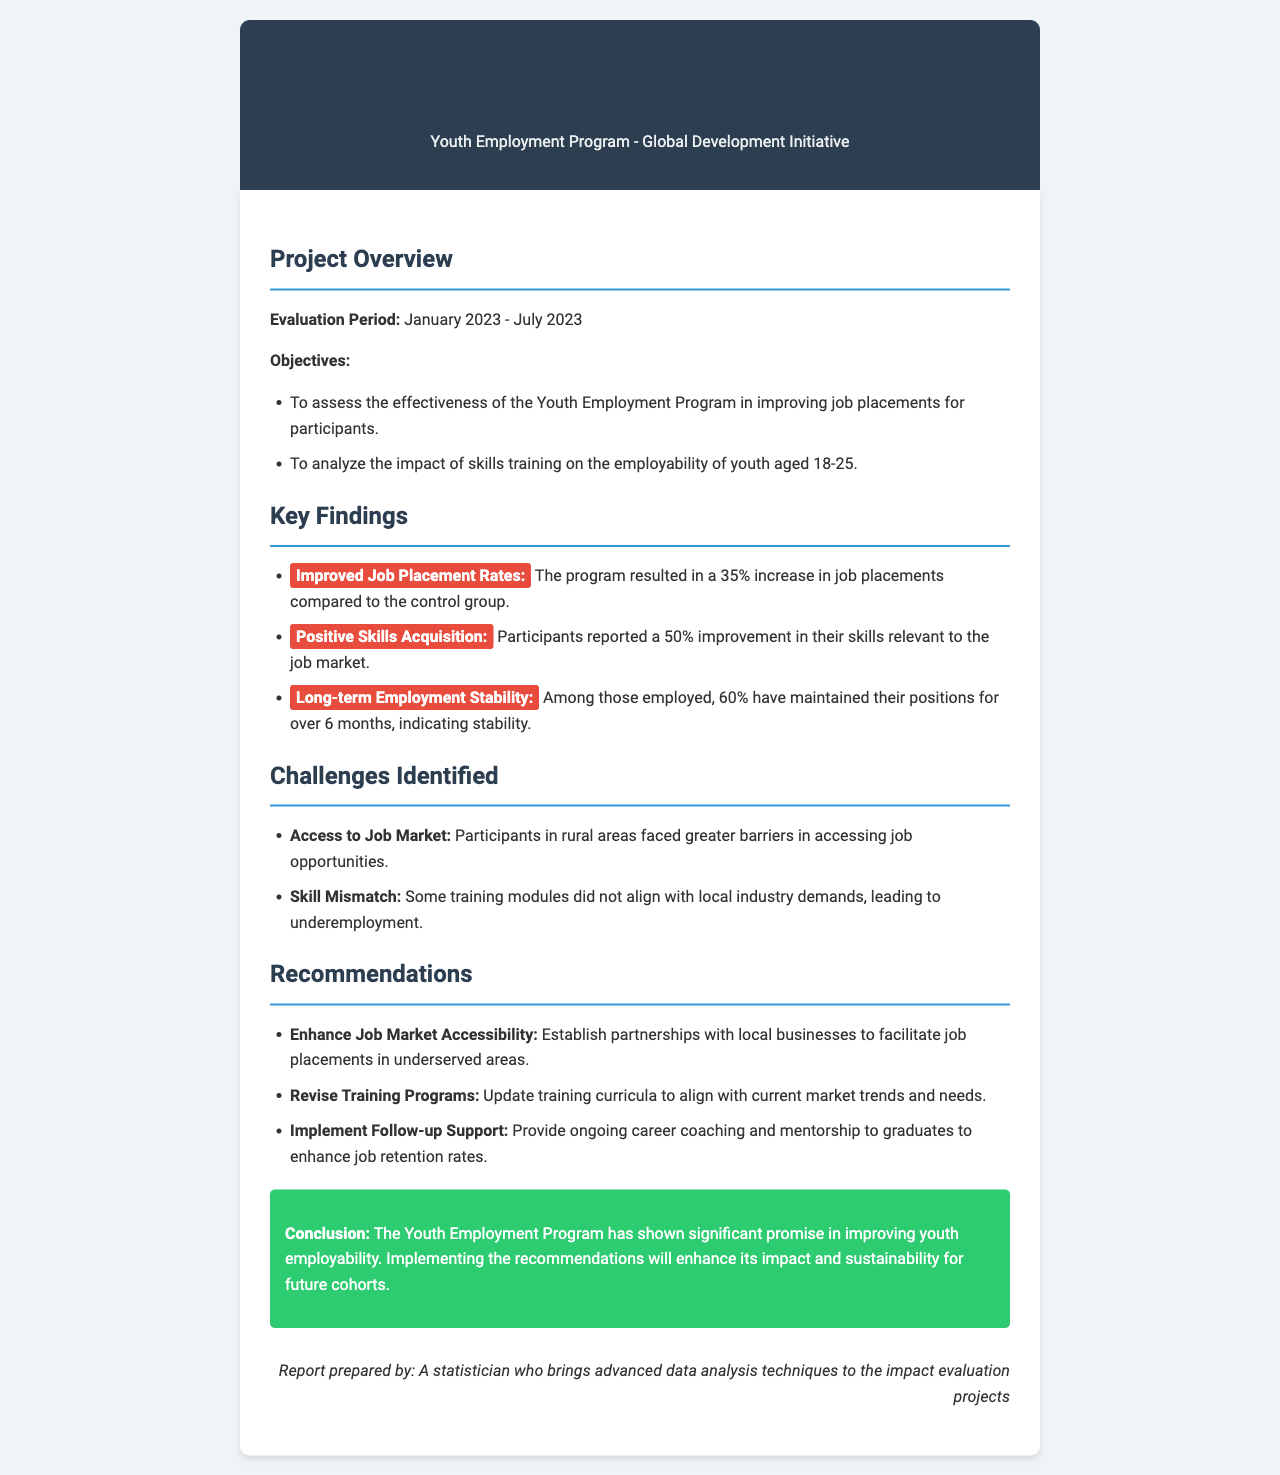What is the title of the report? The title of the report is listed prominently at the top of the document.
Answer: Impact Evaluation Report Summary What is the evaluation period? The evaluation period is specified in the project overview section of the document.
Answer: January 2023 - July 2023 What was the percentage increase in job placements? The percentage increase in job placements is mentioned in the key findings section.
Answer: 35% How many participants maintained their positions for over 6 months? The document specifically states the number of participants who sustained their employment.
Answer: 60% What was identified as a challenge for participants in rural areas? The challenges are detailed in a specific section that discusses various barriers participants faced.
Answer: Access to Job Market What does one recommendation suggest regarding training programs? Recommendations provide specific actions to improve the program's effectiveness, including changes to training.
Answer: Revise Training Programs What was the reported improvement in skills relevant to the job market? The improvement in skills is noted in the key findings section of the report.
Answer: 50% Who prepared the report? The signature section of the document reveals the author of the report.
Answer: A statistician who brings advanced data analysis techniques to the impact evaluation projects What is the main conclusion regarding the Youth Employment Program? The conclusion summarizes the overall findings and implications of the program's effectiveness.
Answer: Significant promise in improving youth employability 